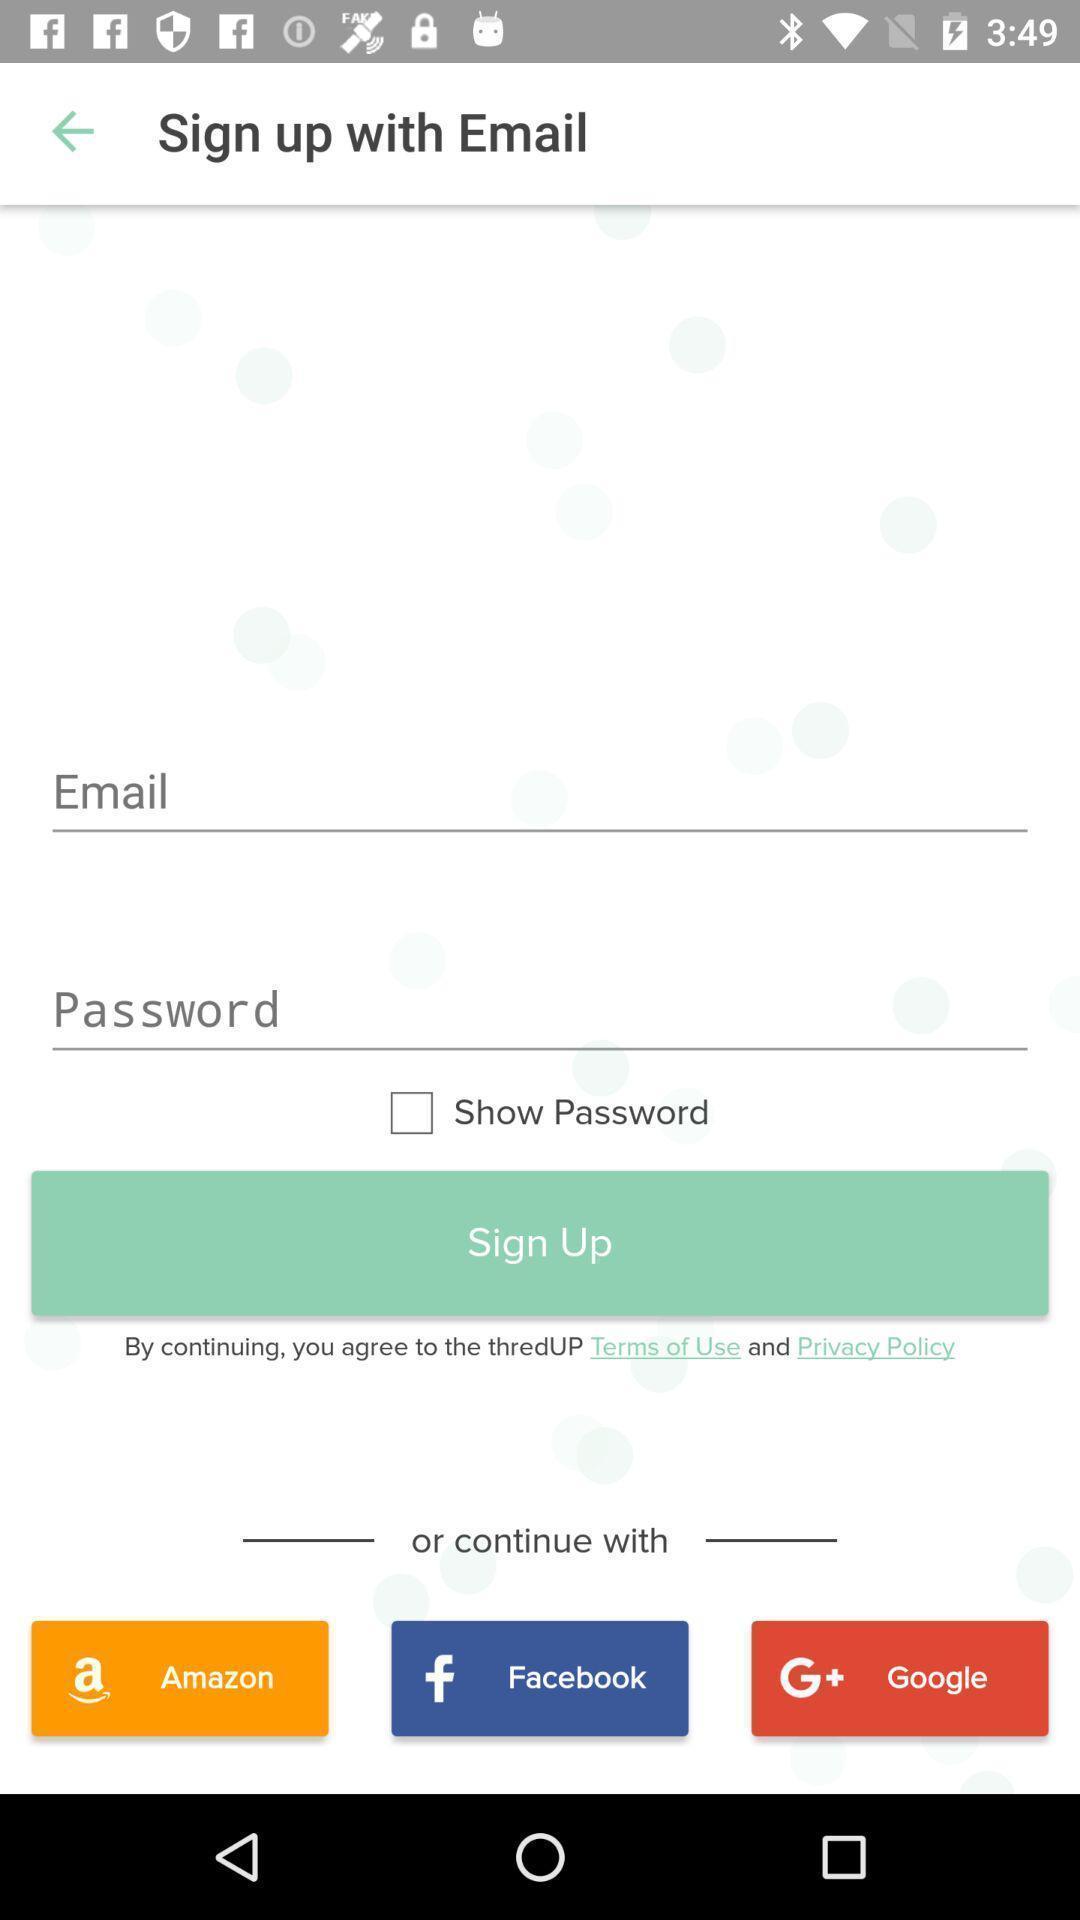Describe the key features of this screenshot. Sign up with email page. 